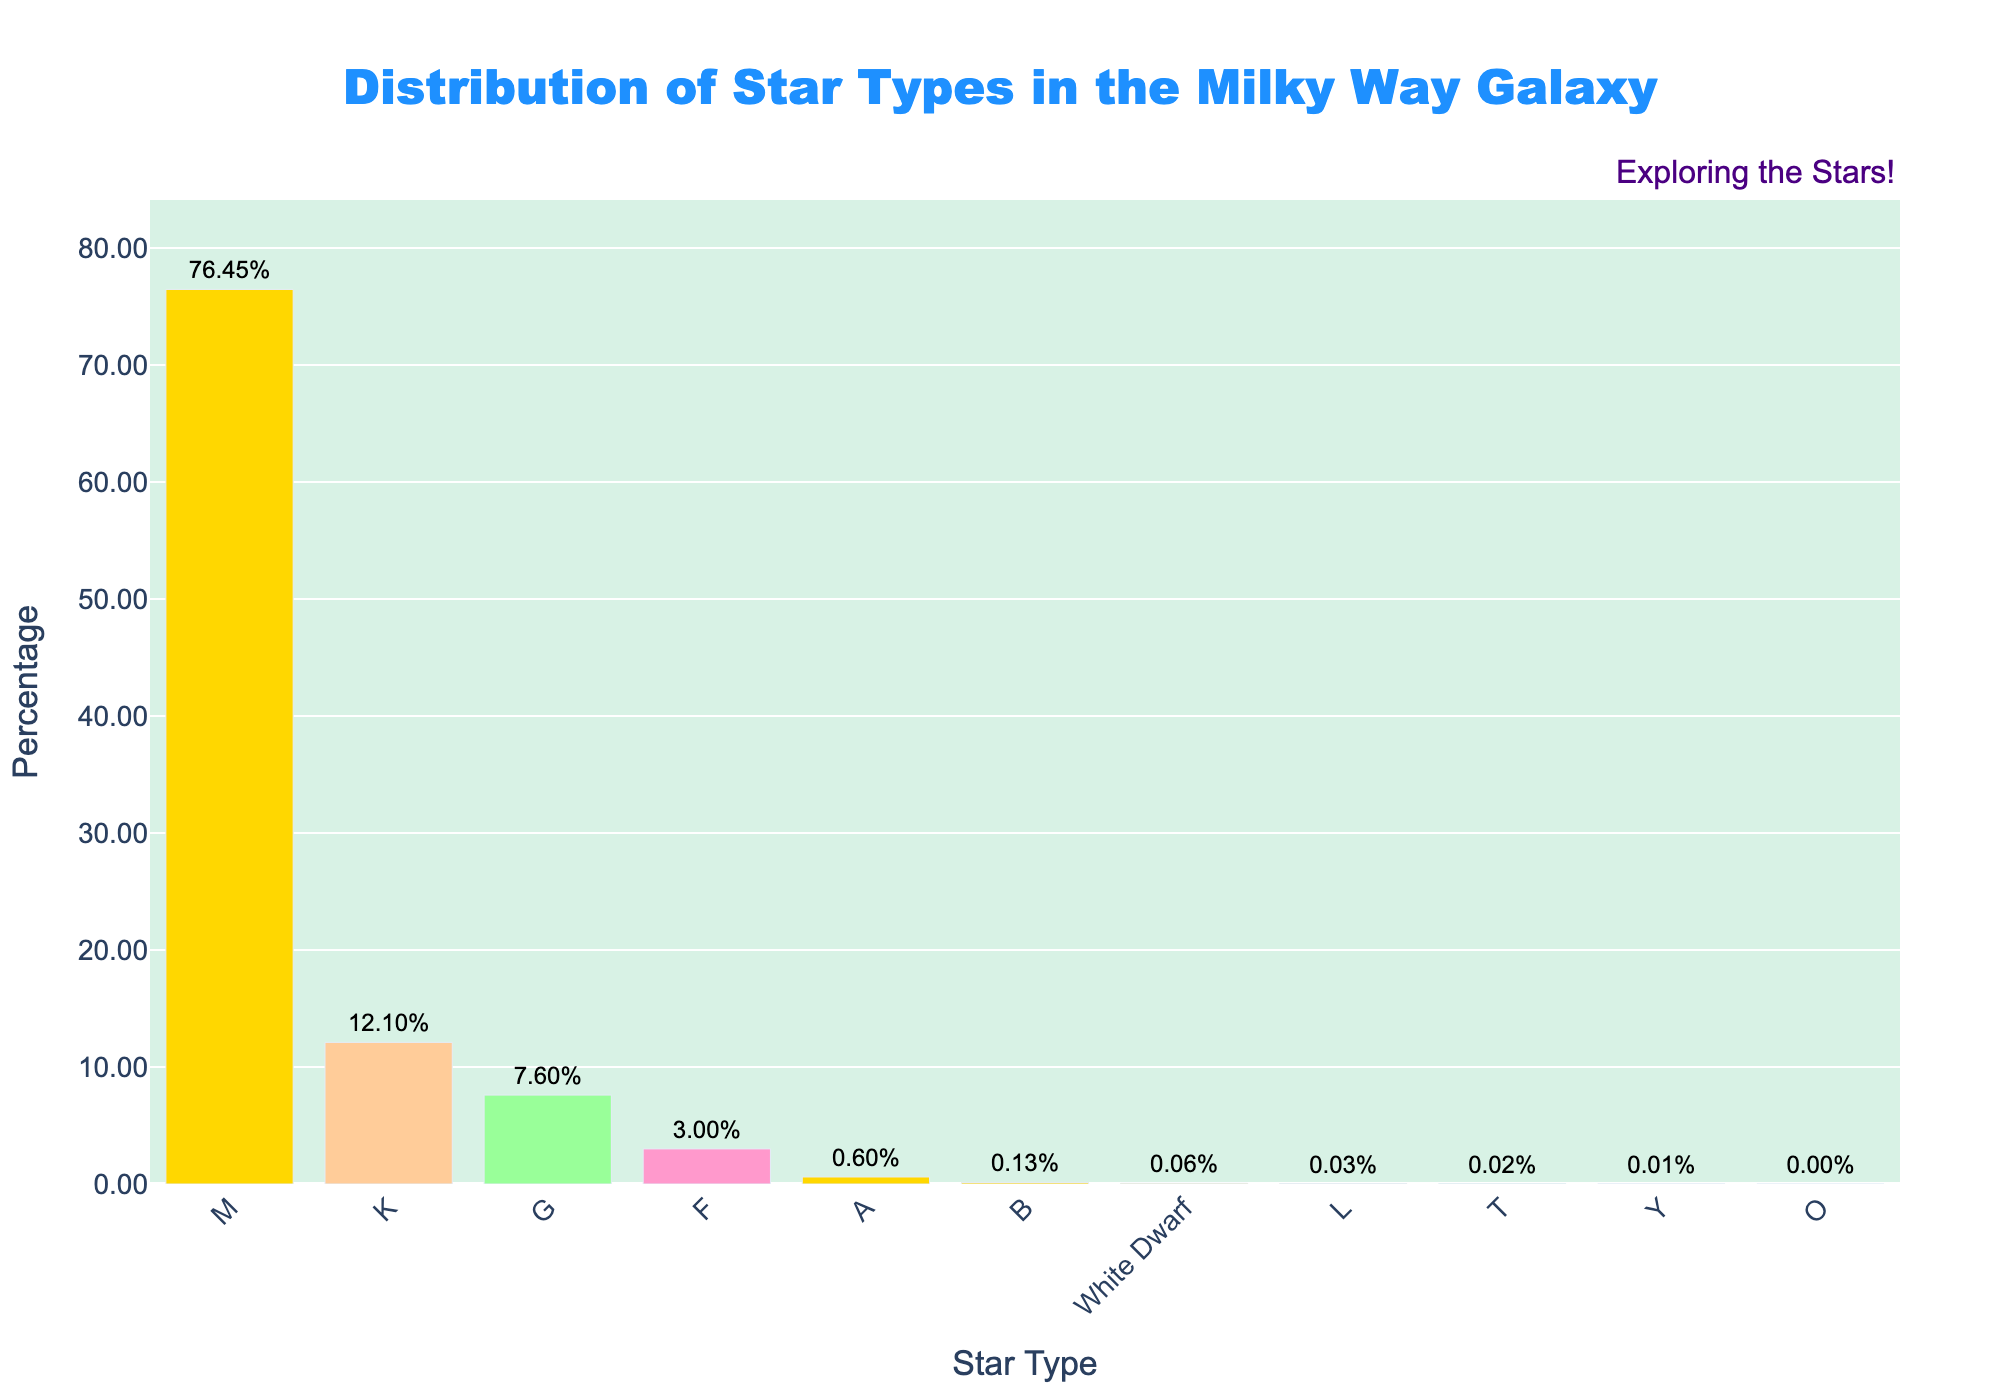What star type has the highest percentage in the Milky Way galaxy? The bar that reaches the highest in the chart represents the star type with the highest percentage. From the chart, it's evident that the "M" star type has the highest bar.
Answer: M How much higher is the percentage of G-type stars compared to F-type stars? To find the difference, look at the heights of the bars for G and F stars. G stars have a percentage of 7.6%, and F stars have a percentage of 3%. Subtracting these, 7.6% - 3% = 4.6%.
Answer: 4.6% Which star type is more common, A or B, and by how much? Compare the heights of the bars for A and B star types. A stars have a percentage of 0.6% and B stars have a percentage of 0.13%. Subtracting these, 0.6% - 0.13% = 0.47%.
Answer: A by 0.47% What is the combined percentage of White Dwarf, L, T, and Y star types? Add up the percentages of White Dwarf (0.06%), L (0.03%), T (0.02%), and Y (0.01%) star types. Sum = 0.06% + 0.03% + 0.02% + 0.01% = 0.12%.
Answer: 0.12% Which star type has a percentage closest to 3%? Identify the star type with a bar closest in height to 3%. From the chart, the F type star has a percentage of exactly 3%.
Answer: F Are there more K-type stars or G-type stars, and by what percentage difference? Compare the heights of bars for K and G stars. K stars have 12.1%, and G stars have 7.6%, so 12.1% - 7.6% = 4.5%.
Answer: K by 4.5% What is the sum of the percentages of O, B, and A star types? Add up the percentages of O (0.00003%), B (0.13%), and A (0.6%) star types. Sum = 0.00003% + 0.13% + 0.6% = 0.73003%.
Answer: 0.73% By how much does the percentage of M-type stars exceed the total percentage of O, L, T, and Y star types combined? First, sum the percentages of O (0.00003%), L (0.03%), T (0.02%), and Y (0.01%). Sum = 0.00003% + 0.03% + 0.02% + 0.01% = 0.06003%. Now, subtract this from the percentage of M-type stars: 76.45% - 0.06003% = 76.38997%.
Answer: 76.39% Do B-type stars or White Dwarfs have a higher percentage, and by how much? Compare the heights of the bars for B stars (0.13%) and White Dwarfs (0.06%). The difference is calculated by 0.13% - 0.06% = 0.07%.
Answer: B by 0.07% What is the average percentage of G, K, and M star types? First, add the percentages of G (7.6%), K (12.1%), and M (76.45%). Sum = 7.6% + 12.1% + 76.45% = 96.15%. Then, divide by 3 (number of star types): 96.15% / 3 = 32.05%.
Answer: 32.05% 